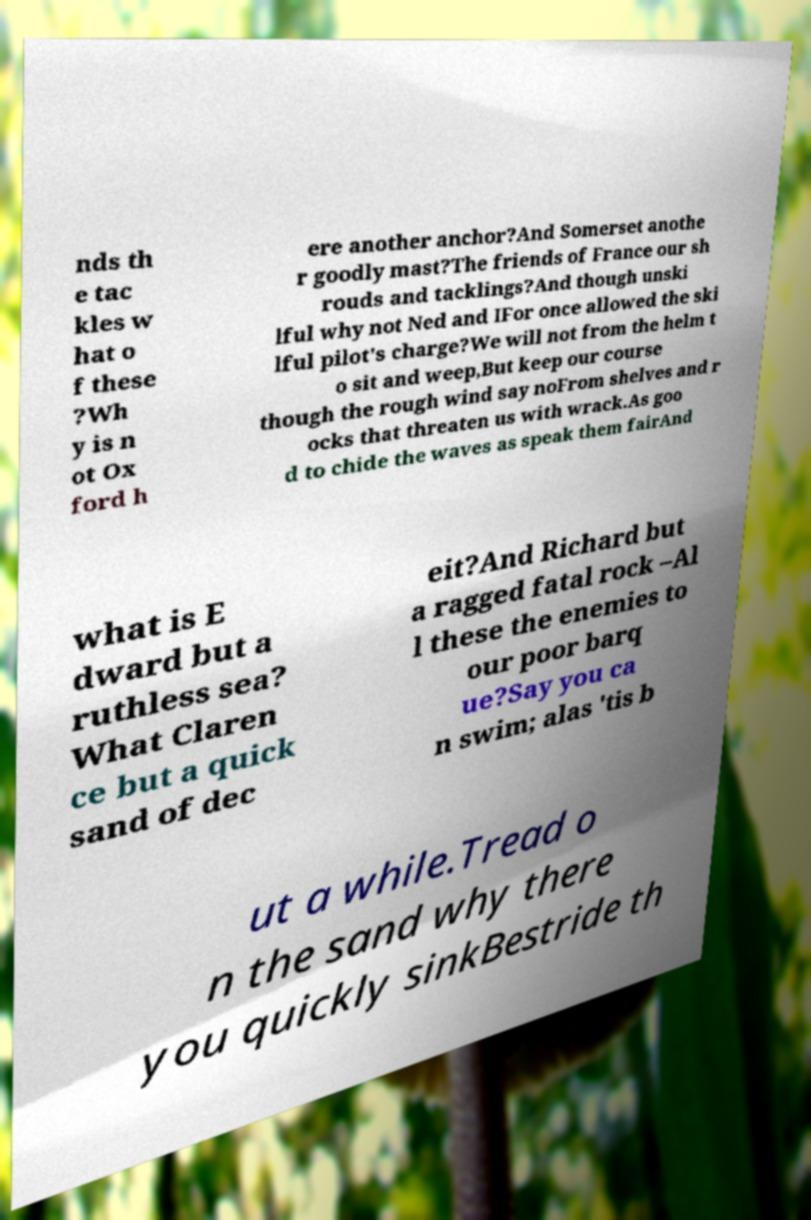Could you extract and type out the text from this image? nds th e tac kles w hat o f these ?Wh y is n ot Ox ford h ere another anchor?And Somerset anothe r goodly mast?The friends of France our sh rouds and tacklings?And though unski lful why not Ned and IFor once allowed the ski lful pilot's charge?We will not from the helm t o sit and weep,But keep our course though the rough wind say noFrom shelves and r ocks that threaten us with wrack.As goo d to chide the waves as speak them fairAnd what is E dward but a ruthless sea? What Claren ce but a quick sand of dec eit?And Richard but a ragged fatal rock –Al l these the enemies to our poor barq ue?Say you ca n swim; alas 'tis b ut a while.Tread o n the sand why there you quickly sinkBestride th 